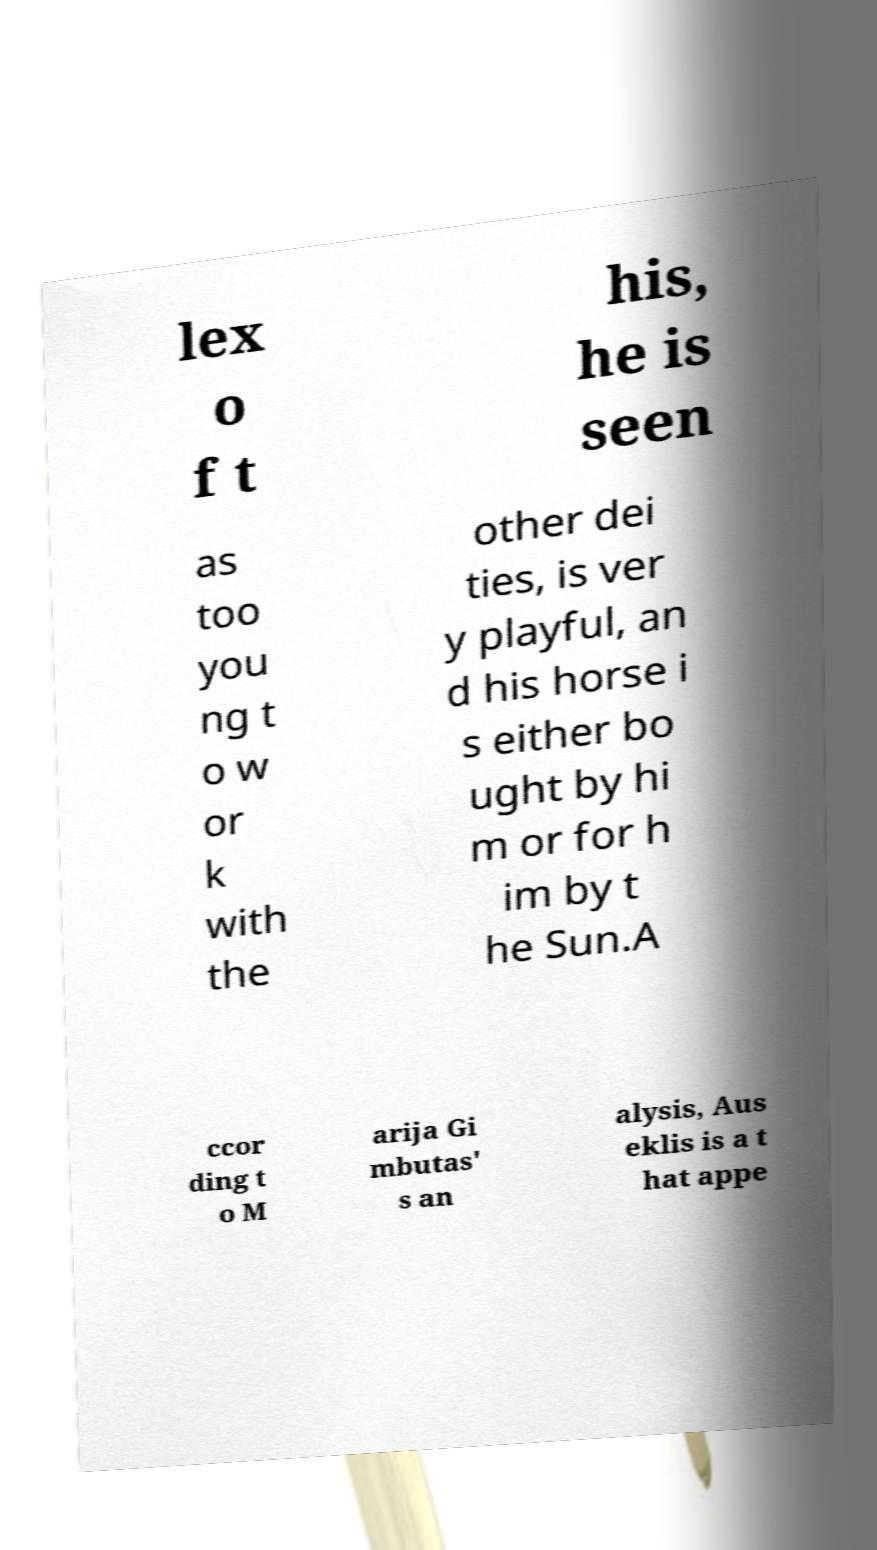There's text embedded in this image that I need extracted. Can you transcribe it verbatim? lex o f t his, he is seen as too you ng t o w or k with the other dei ties, is ver y playful, an d his horse i s either bo ught by hi m or for h im by t he Sun.A ccor ding t o M arija Gi mbutas' s an alysis, Aus eklis is a t hat appe 